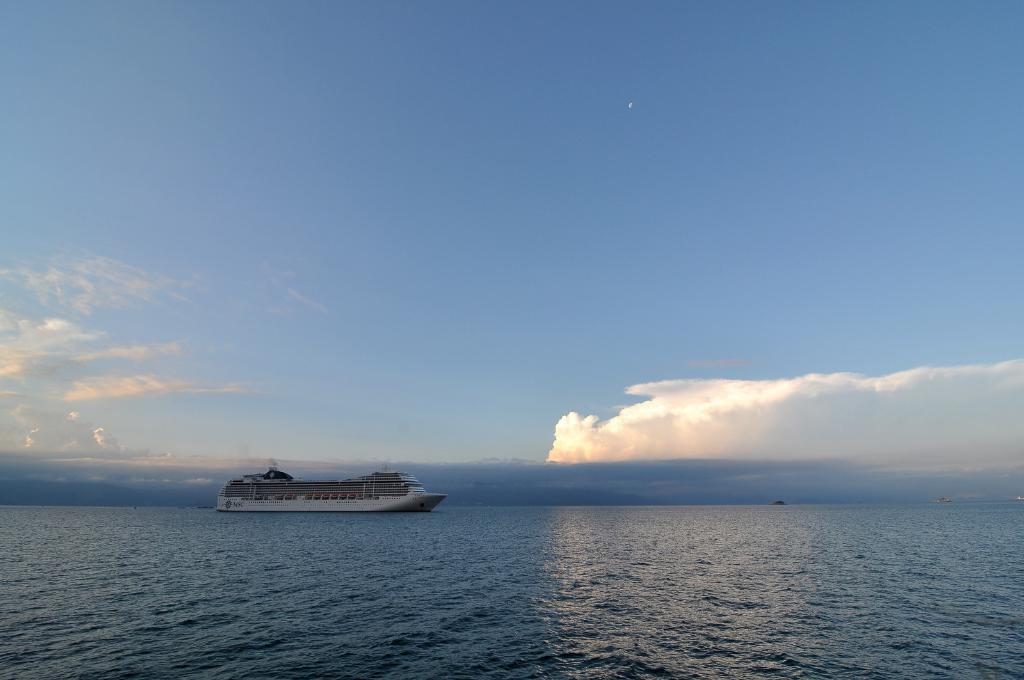Could you give a brief overview of what you see in this image? In this picture, we can see a ship on the water and behind the ship there is a sky. 